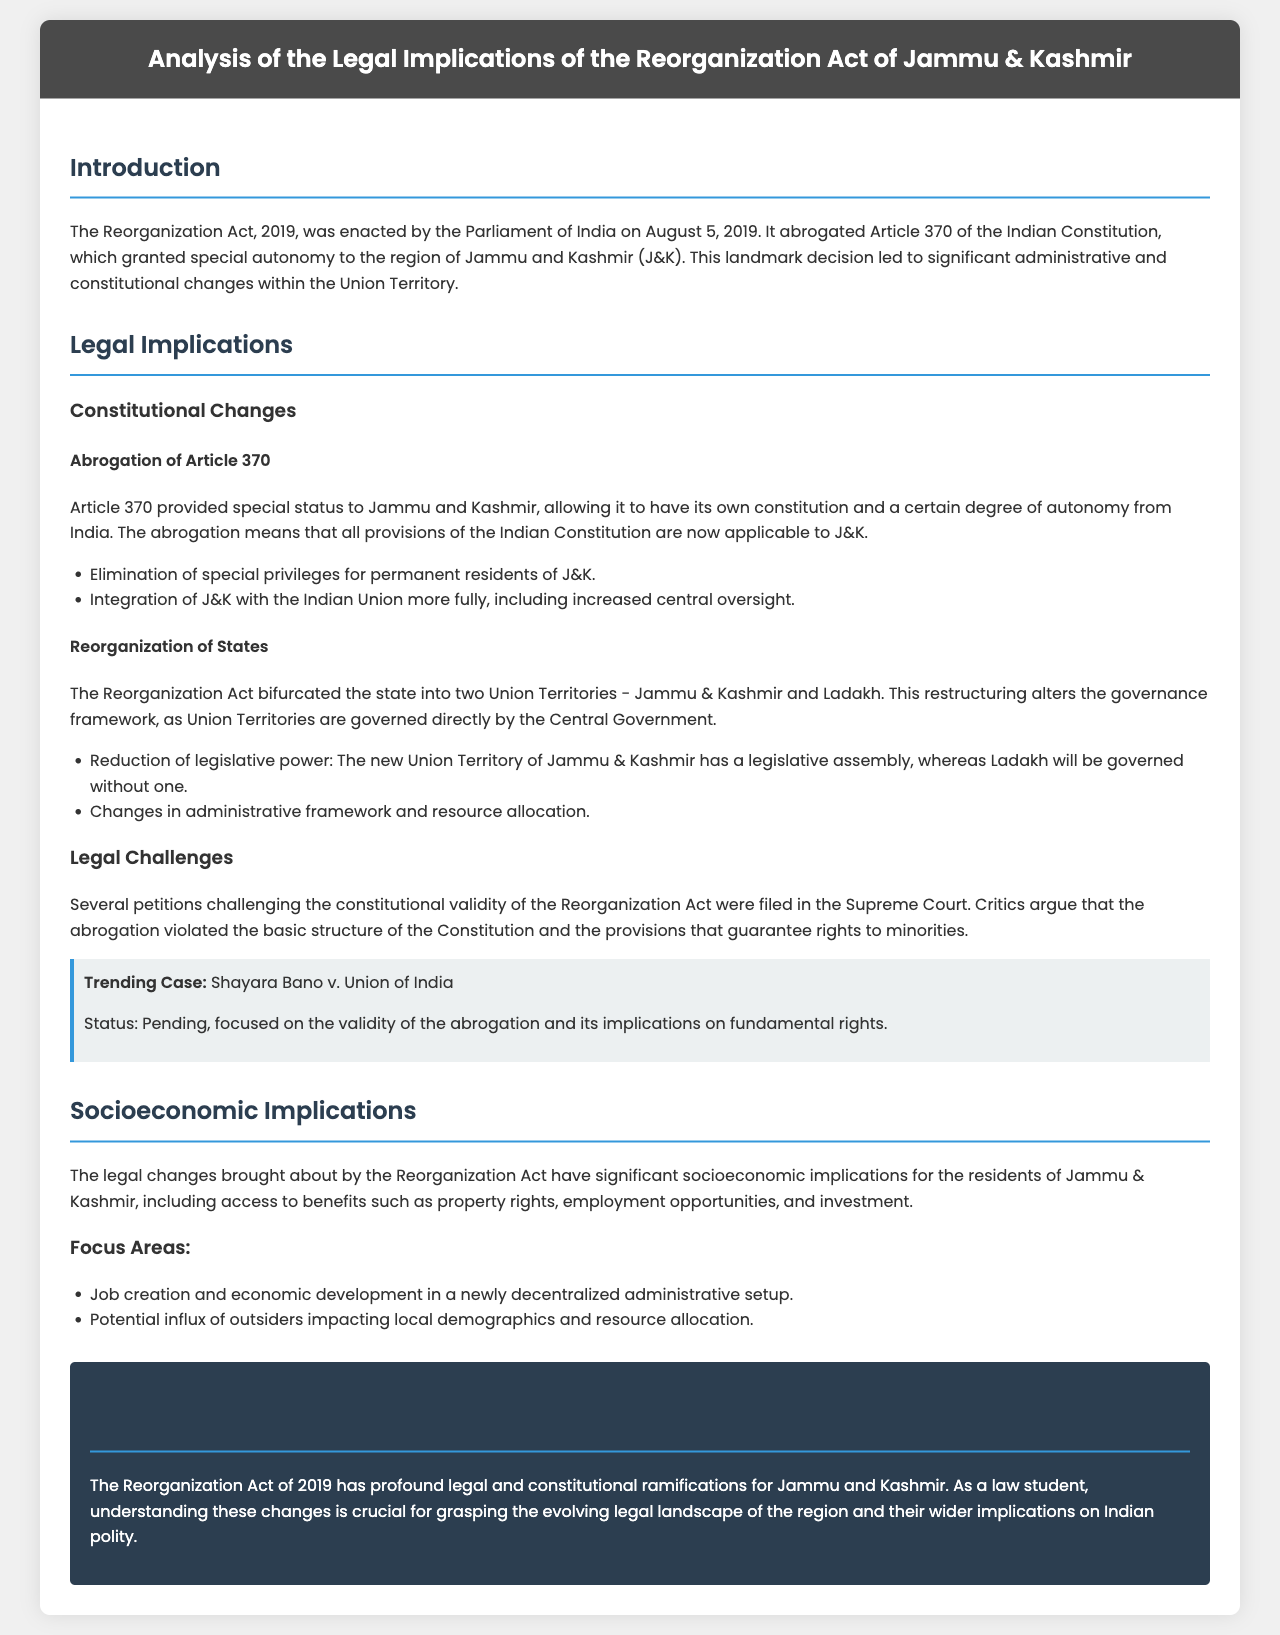What Act was enacted on August 5, 2019? The document states that the Reorganization Act was enacted by the Parliament of India on August 5, 2019.
Answer: Reorganization Act What Article was abrogated by the Reorganization Act? The Reorganization Act abrogated Article 370, which granted special autonomy to Jammu and Kashmir.
Answer: Article 370 How many Union Territories were created after the Reorganization Act? The Reorganization Act bifurcated the state into two Union Territories.
Answer: Two What is the status of the case Shayara Bano v. Union of India? The document mentions that the case status is pending, focusing on the validity of the abrogation.
Answer: Pending What significant change occurred regarding the governance of Jammu and Kashmir? The governance framework changed as Union Territories are governed directly by the Central Government.
Answer: Direct governance by Central Government Which area has no legislative assembly after the reorganization? The document states that Ladakh will be governed without a legislative assembly.
Answer: Ladakh What socioeconomic effect is highlighted in the document regarding the Reorganization Act? The document highlights access to benefits such as property rights and employment opportunities.
Answer: Access to benefits What is stated as a focus area for socioeconomic implications post-reorganization? Job creation and economic development in a newly decentralized administrative setup are identified as focus areas.
Answer: Job creation and economic development 